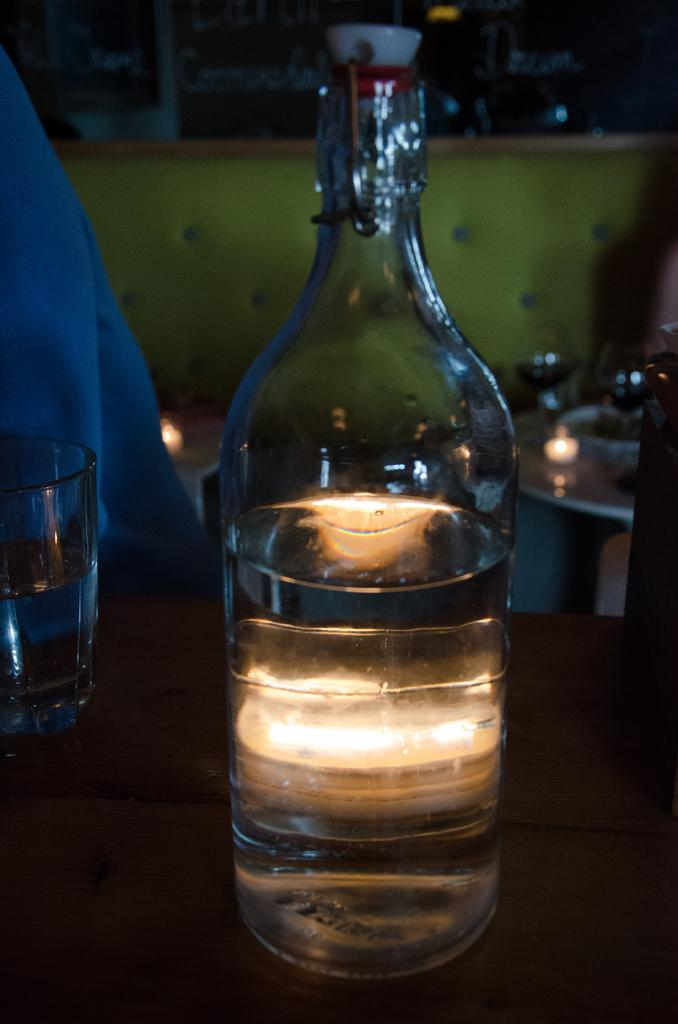What is inside the glass bottle that is visible in the image? There is a liquid in the glass bottle in the image. What other glass object is visible in the image? There is a glass visible in the image. Where are the glass bottle and glass located in the image? The glass bottle and glass are on a table in the image. What type of door can be seen in the image? There is no door present in the image. How many cubs are visible in the image? There are no cubs present in the image. 